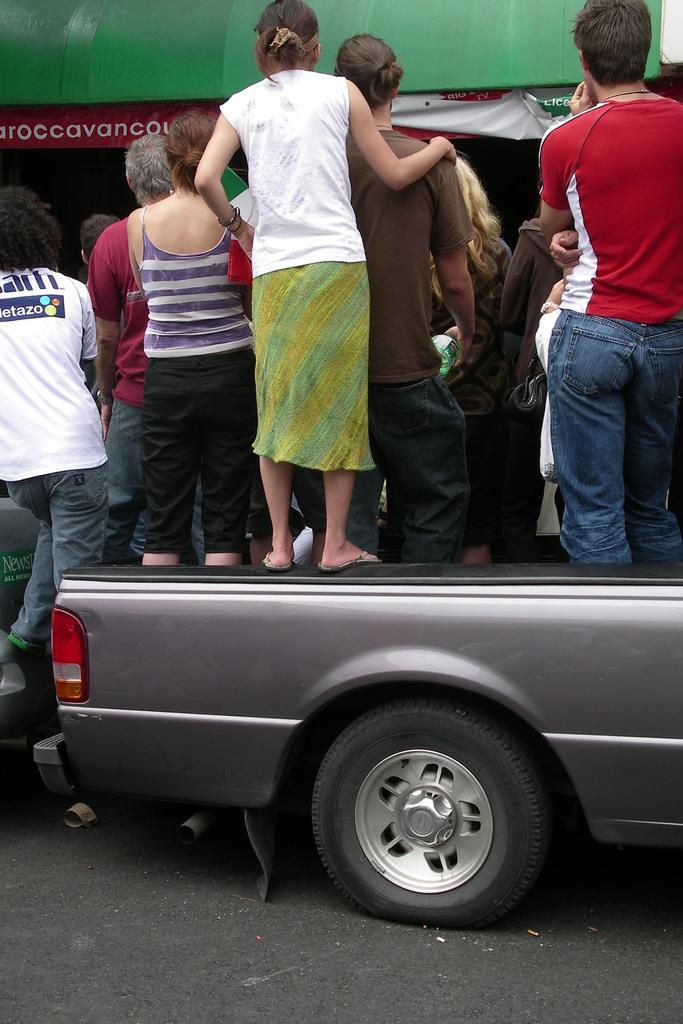In one or two sentences, can you explain what this image depicts? In this image we can see some group of persons standing and some are standing on the vehicle which is of grey color and at the background of the image there is green color shade. 